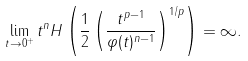Convert formula to latex. <formula><loc_0><loc_0><loc_500><loc_500>\lim _ { t \to 0 ^ { + } } t ^ { n } H \left ( \frac { 1 } { 2 } \left ( \frac { t ^ { p - 1 } } { \varphi ( t ) ^ { n - 1 } } \right ) ^ { 1 / p } \right ) = \infty .</formula> 